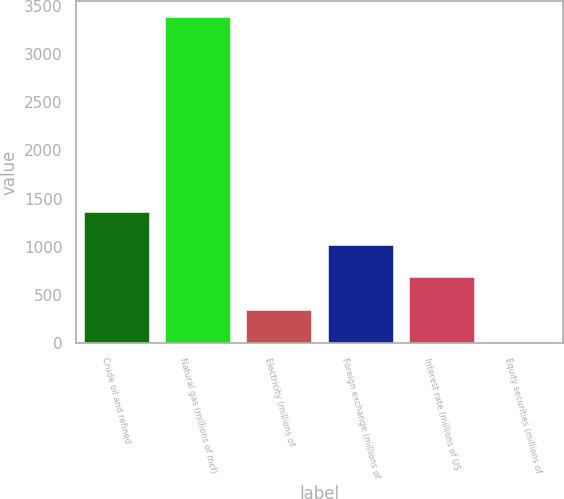<chart> <loc_0><loc_0><loc_500><loc_500><bar_chart><fcel>Crude oil and refined<fcel>Natural gas (millions of mcf)<fcel>Electricity (millions of<fcel>Foreign exchange (millions of<fcel>Interest rate (millions of US<fcel>Equity securities (millions of<nl><fcel>1359.2<fcel>3377<fcel>350.3<fcel>1022.9<fcel>686.6<fcel>14<nl></chart> 